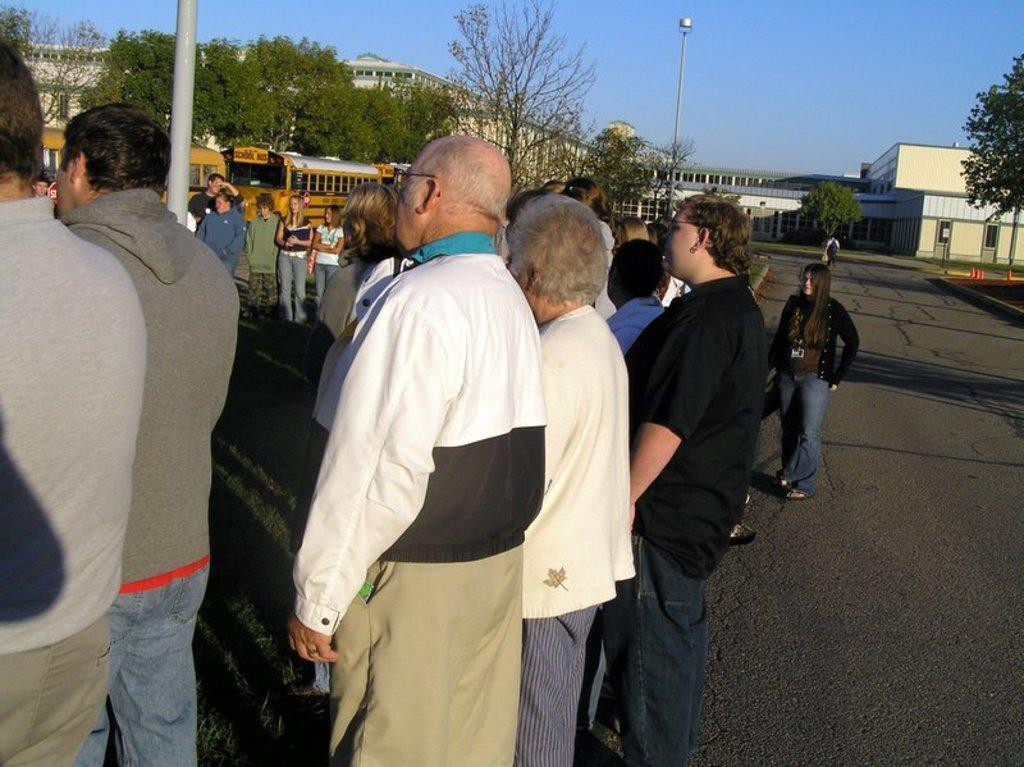What are the people in the image doing near the pole? The people are standing near a pole in the image. Where are the people located in the image? The people are on a road in the image. What can be seen in the background of the image? There are trees, buses, buildings, and the sky visible in the background of the image. What type of root can be seen growing on the pole in the image? There is no root growing on the pole in the image. What disease is affecting the people standing near the pole in the image? There is no indication of any disease affecting the people in the image. 